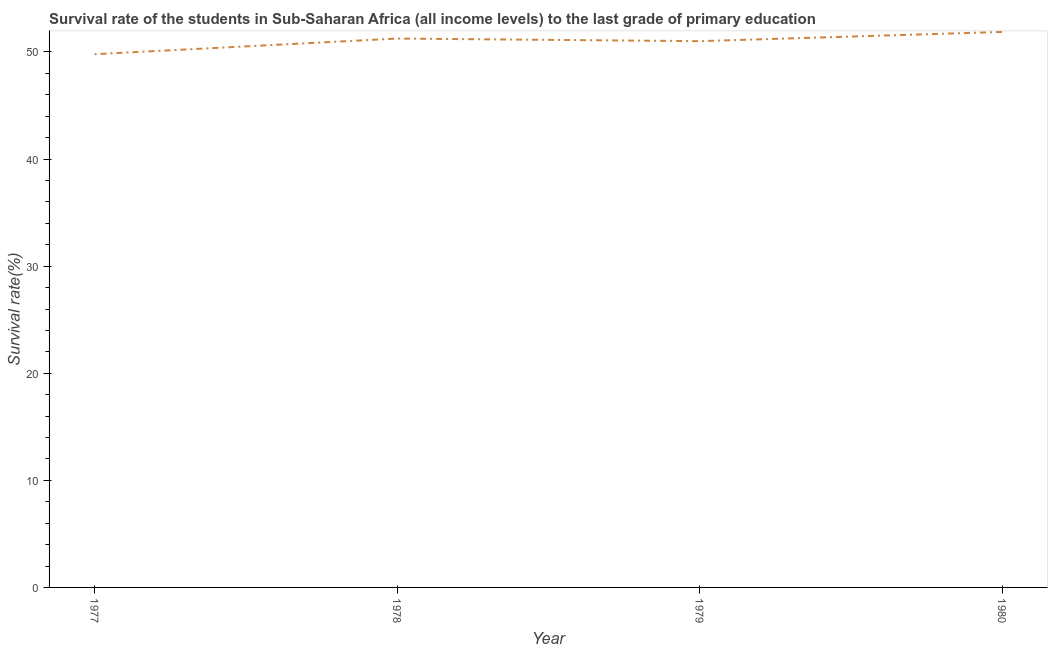What is the survival rate in primary education in 1978?
Provide a short and direct response. 51.26. Across all years, what is the maximum survival rate in primary education?
Make the answer very short. 51.87. Across all years, what is the minimum survival rate in primary education?
Your answer should be very brief. 49.79. In which year was the survival rate in primary education minimum?
Offer a terse response. 1977. What is the sum of the survival rate in primary education?
Provide a succinct answer. 203.93. What is the difference between the survival rate in primary education in 1978 and 1979?
Offer a very short reply. 0.24. What is the average survival rate in primary education per year?
Your answer should be compact. 50.98. What is the median survival rate in primary education?
Offer a very short reply. 51.13. In how many years, is the survival rate in primary education greater than 6 %?
Your answer should be very brief. 4. What is the ratio of the survival rate in primary education in 1977 to that in 1978?
Make the answer very short. 0.97. Is the survival rate in primary education in 1978 less than that in 1980?
Provide a succinct answer. Yes. Is the difference between the survival rate in primary education in 1977 and 1979 greater than the difference between any two years?
Keep it short and to the point. No. What is the difference between the highest and the second highest survival rate in primary education?
Ensure brevity in your answer.  0.62. What is the difference between the highest and the lowest survival rate in primary education?
Offer a very short reply. 2.08. In how many years, is the survival rate in primary education greater than the average survival rate in primary education taken over all years?
Keep it short and to the point. 3. Does the graph contain any zero values?
Make the answer very short. No. Does the graph contain grids?
Provide a short and direct response. No. What is the title of the graph?
Your response must be concise. Survival rate of the students in Sub-Saharan Africa (all income levels) to the last grade of primary education. What is the label or title of the Y-axis?
Offer a very short reply. Survival rate(%). What is the Survival rate(%) of 1977?
Offer a terse response. 49.79. What is the Survival rate(%) of 1978?
Ensure brevity in your answer.  51.26. What is the Survival rate(%) of 1979?
Your answer should be compact. 51.01. What is the Survival rate(%) in 1980?
Your answer should be compact. 51.87. What is the difference between the Survival rate(%) in 1977 and 1978?
Your answer should be very brief. -1.46. What is the difference between the Survival rate(%) in 1977 and 1979?
Your answer should be very brief. -1.22. What is the difference between the Survival rate(%) in 1977 and 1980?
Your answer should be compact. -2.08. What is the difference between the Survival rate(%) in 1978 and 1979?
Give a very brief answer. 0.24. What is the difference between the Survival rate(%) in 1978 and 1980?
Give a very brief answer. -0.62. What is the difference between the Survival rate(%) in 1979 and 1980?
Your answer should be compact. -0.86. What is the ratio of the Survival rate(%) in 1977 to that in 1978?
Your answer should be very brief. 0.97. What is the ratio of the Survival rate(%) in 1977 to that in 1979?
Your response must be concise. 0.98. What is the ratio of the Survival rate(%) in 1977 to that in 1980?
Provide a short and direct response. 0.96. What is the ratio of the Survival rate(%) in 1978 to that in 1980?
Provide a succinct answer. 0.99. 